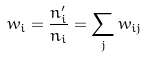Convert formula to latex. <formula><loc_0><loc_0><loc_500><loc_500>w _ { i } = \frac { n _ { i } ^ { \prime } } { n _ { i } } = \sum _ { j } w _ { i j }</formula> 